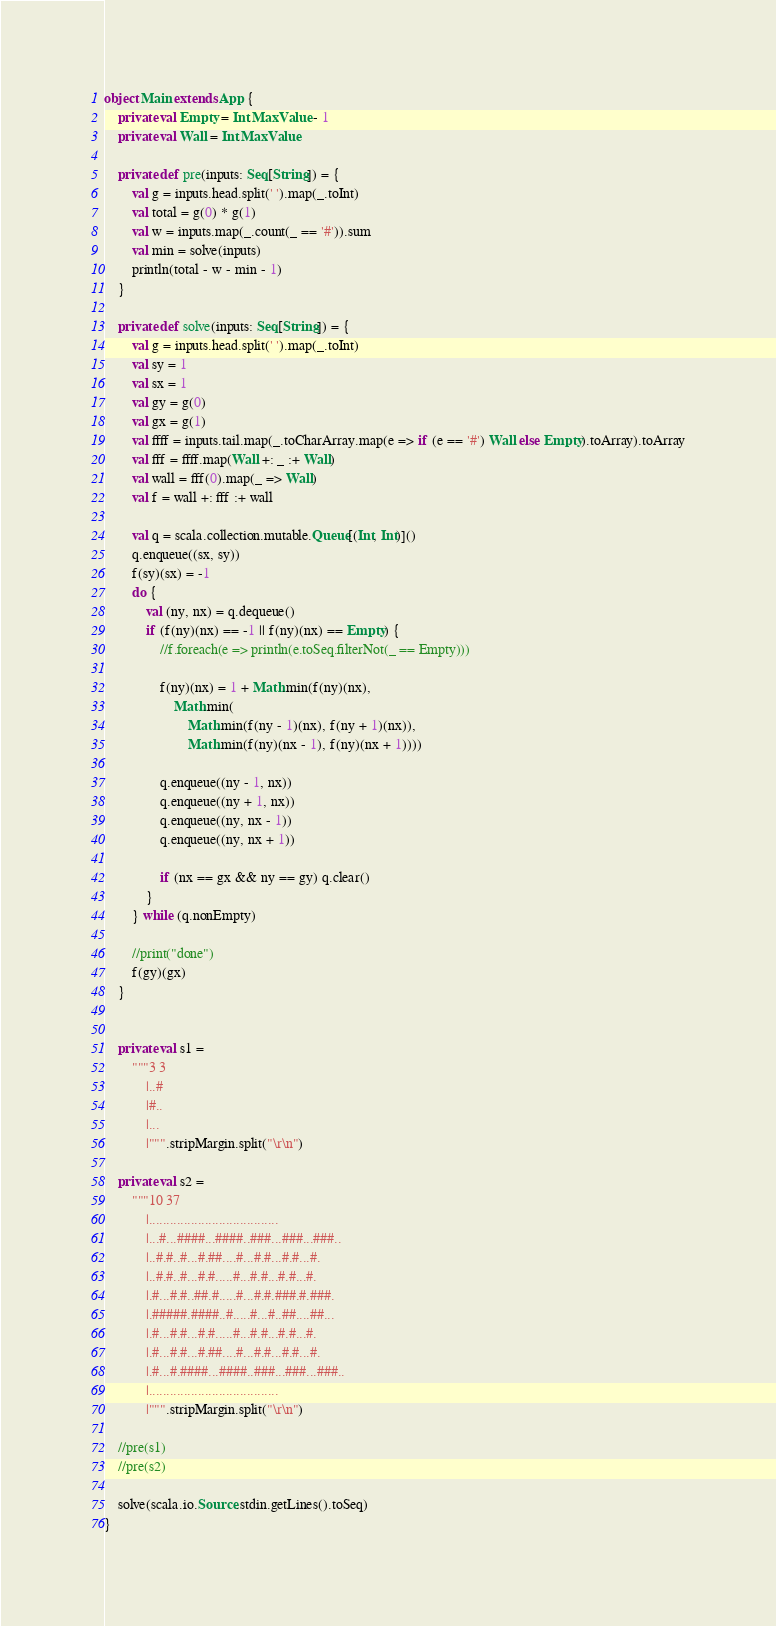<code> <loc_0><loc_0><loc_500><loc_500><_Scala_>object Main extends App {
	private val Empty = Int.MaxValue - 1
	private val Wall = Int.MaxValue

	private def pre(inputs: Seq[String]) = {
		val g = inputs.head.split(' ').map(_.toInt)
		val total = g(0) * g(1)
		val w = inputs.map(_.count(_ == '#')).sum
		val min = solve(inputs)
		println(total - w - min - 1)
	}

	private def solve(inputs: Seq[String]) = {
		val g = inputs.head.split(' ').map(_.toInt)
		val sy = 1
		val sx = 1
		val gy = g(0)
		val gx = g(1)
		val ffff = inputs.tail.map(_.toCharArray.map(e => if (e == '#') Wall else Empty).toArray).toArray
		val fff = ffff.map(Wall +: _ :+ Wall)
		val wall = fff(0).map(_ => Wall)
		val f = wall +: fff :+ wall

		val q = scala.collection.mutable.Queue[(Int, Int)]()
		q.enqueue((sx, sy))
		f(sy)(sx) = -1
		do {
			val (ny, nx) = q.dequeue()
			if (f(ny)(nx) == -1 || f(ny)(nx) == Empty) {
				//f.foreach(e => println(e.toSeq.filterNot(_ == Empty)))

				f(ny)(nx) = 1 + Math.min(f(ny)(nx),
					Math.min(
						Math.min(f(ny - 1)(nx), f(ny + 1)(nx)),
						Math.min(f(ny)(nx - 1), f(ny)(nx + 1))))

				q.enqueue((ny - 1, nx))
				q.enqueue((ny + 1, nx))
				q.enqueue((ny, nx - 1))
				q.enqueue((ny, nx + 1))

				if (nx == gx && ny == gy) q.clear()
			}
		} while (q.nonEmpty)

		//print("done")
		f(gy)(gx)
	}


	private val s1 =
		"""3 3
			|..#
			|#..
			|...
			|""".stripMargin.split("\r\n")

	private val s2 =
		"""10 37
			|.....................................
			|...#...####...####..###...###...###..
			|..#.#..#...#.##....#...#.#...#.#...#.
			|..#.#..#...#.#.....#...#.#...#.#...#.
			|.#...#.#..##.#.....#...#.#.###.#.###.
			|.#####.####..#.....#...#..##....##...
			|.#...#.#...#.#.....#...#.#...#.#...#.
			|.#...#.#...#.##....#...#.#...#.#...#.
			|.#...#.####...####..###...###...###..
			|.....................................
			|""".stripMargin.split("\r\n")

	//pre(s1)
	//pre(s2)

	solve(scala.io.Source.stdin.getLines().toSeq)
}
</code> 